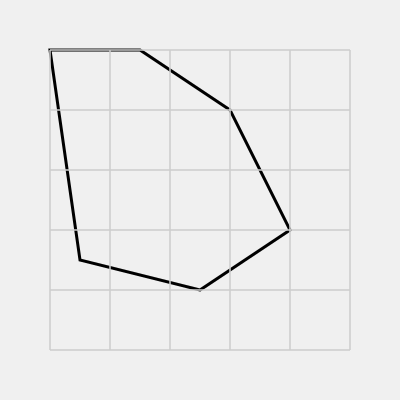Given the irregular polygon shown on the grid, where each square represents 1 square unit, estimate the area of the polygon using the counting squares method. Round your answer to the nearest whole number. To estimate the area of the irregular polygon using the grid system, we'll follow these steps:

1. Count the full squares inside the polygon:
   There are approximately 33 full squares inside the polygon.

2. Count the partial squares along the boundary:
   There are about 22 partial squares along the boundary.

3. Estimate the area of partial squares:
   We can assume that, on average, each partial square contributes about half its area to the polygon. So, we'll count each partial square as 0.5.

4. Calculate the total estimated area:
   $$ \text{Area} = \text{Full squares} + (\text{Partial squares} \times 0.5) $$
   $$ \text{Area} = 33 + (22 \times 0.5) $$
   $$ \text{Area} = 33 + 11 = 44 \text{ square units} $$

5. Round to the nearest whole number:
   The estimated area is already a whole number, so no rounding is needed.

This method provides a reasonable estimate of the area for irregular shapes using a grid system, which is particularly useful when working with complex shapes or when precise measurements are not available.
Answer: 44 square units 